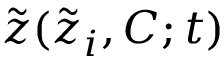<formula> <loc_0><loc_0><loc_500><loc_500>\tilde { z } ( \tilde { z } _ { i } , C ; t )</formula> 